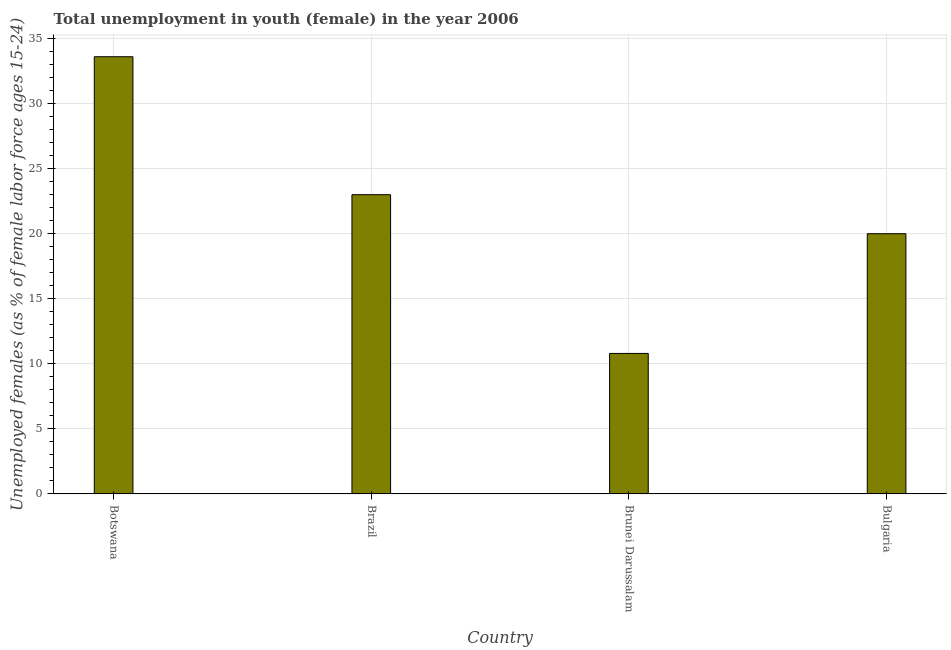Does the graph contain any zero values?
Ensure brevity in your answer.  No. What is the title of the graph?
Give a very brief answer. Total unemployment in youth (female) in the year 2006. What is the label or title of the X-axis?
Provide a short and direct response. Country. What is the label or title of the Y-axis?
Provide a short and direct response. Unemployed females (as % of female labor force ages 15-24). What is the unemployed female youth population in Botswana?
Provide a short and direct response. 33.6. Across all countries, what is the maximum unemployed female youth population?
Give a very brief answer. 33.6. Across all countries, what is the minimum unemployed female youth population?
Provide a succinct answer. 10.8. In which country was the unemployed female youth population maximum?
Offer a very short reply. Botswana. In which country was the unemployed female youth population minimum?
Offer a terse response. Brunei Darussalam. What is the sum of the unemployed female youth population?
Your answer should be very brief. 87.4. What is the difference between the unemployed female youth population in Botswana and Bulgaria?
Your response must be concise. 13.6. What is the average unemployed female youth population per country?
Ensure brevity in your answer.  21.85. In how many countries, is the unemployed female youth population greater than 2 %?
Make the answer very short. 4. What is the ratio of the unemployed female youth population in Brunei Darussalam to that in Bulgaria?
Keep it short and to the point. 0.54. What is the difference between the highest and the second highest unemployed female youth population?
Provide a succinct answer. 10.6. What is the difference between the highest and the lowest unemployed female youth population?
Provide a succinct answer. 22.8. How many bars are there?
Your response must be concise. 4. What is the difference between two consecutive major ticks on the Y-axis?
Offer a terse response. 5. Are the values on the major ticks of Y-axis written in scientific E-notation?
Give a very brief answer. No. What is the Unemployed females (as % of female labor force ages 15-24) of Botswana?
Ensure brevity in your answer.  33.6. What is the Unemployed females (as % of female labor force ages 15-24) of Brunei Darussalam?
Your answer should be compact. 10.8. What is the difference between the Unemployed females (as % of female labor force ages 15-24) in Botswana and Brunei Darussalam?
Offer a very short reply. 22.8. What is the ratio of the Unemployed females (as % of female labor force ages 15-24) in Botswana to that in Brazil?
Keep it short and to the point. 1.46. What is the ratio of the Unemployed females (as % of female labor force ages 15-24) in Botswana to that in Brunei Darussalam?
Make the answer very short. 3.11. What is the ratio of the Unemployed females (as % of female labor force ages 15-24) in Botswana to that in Bulgaria?
Your response must be concise. 1.68. What is the ratio of the Unemployed females (as % of female labor force ages 15-24) in Brazil to that in Brunei Darussalam?
Ensure brevity in your answer.  2.13. What is the ratio of the Unemployed females (as % of female labor force ages 15-24) in Brazil to that in Bulgaria?
Provide a short and direct response. 1.15. What is the ratio of the Unemployed females (as % of female labor force ages 15-24) in Brunei Darussalam to that in Bulgaria?
Keep it short and to the point. 0.54. 